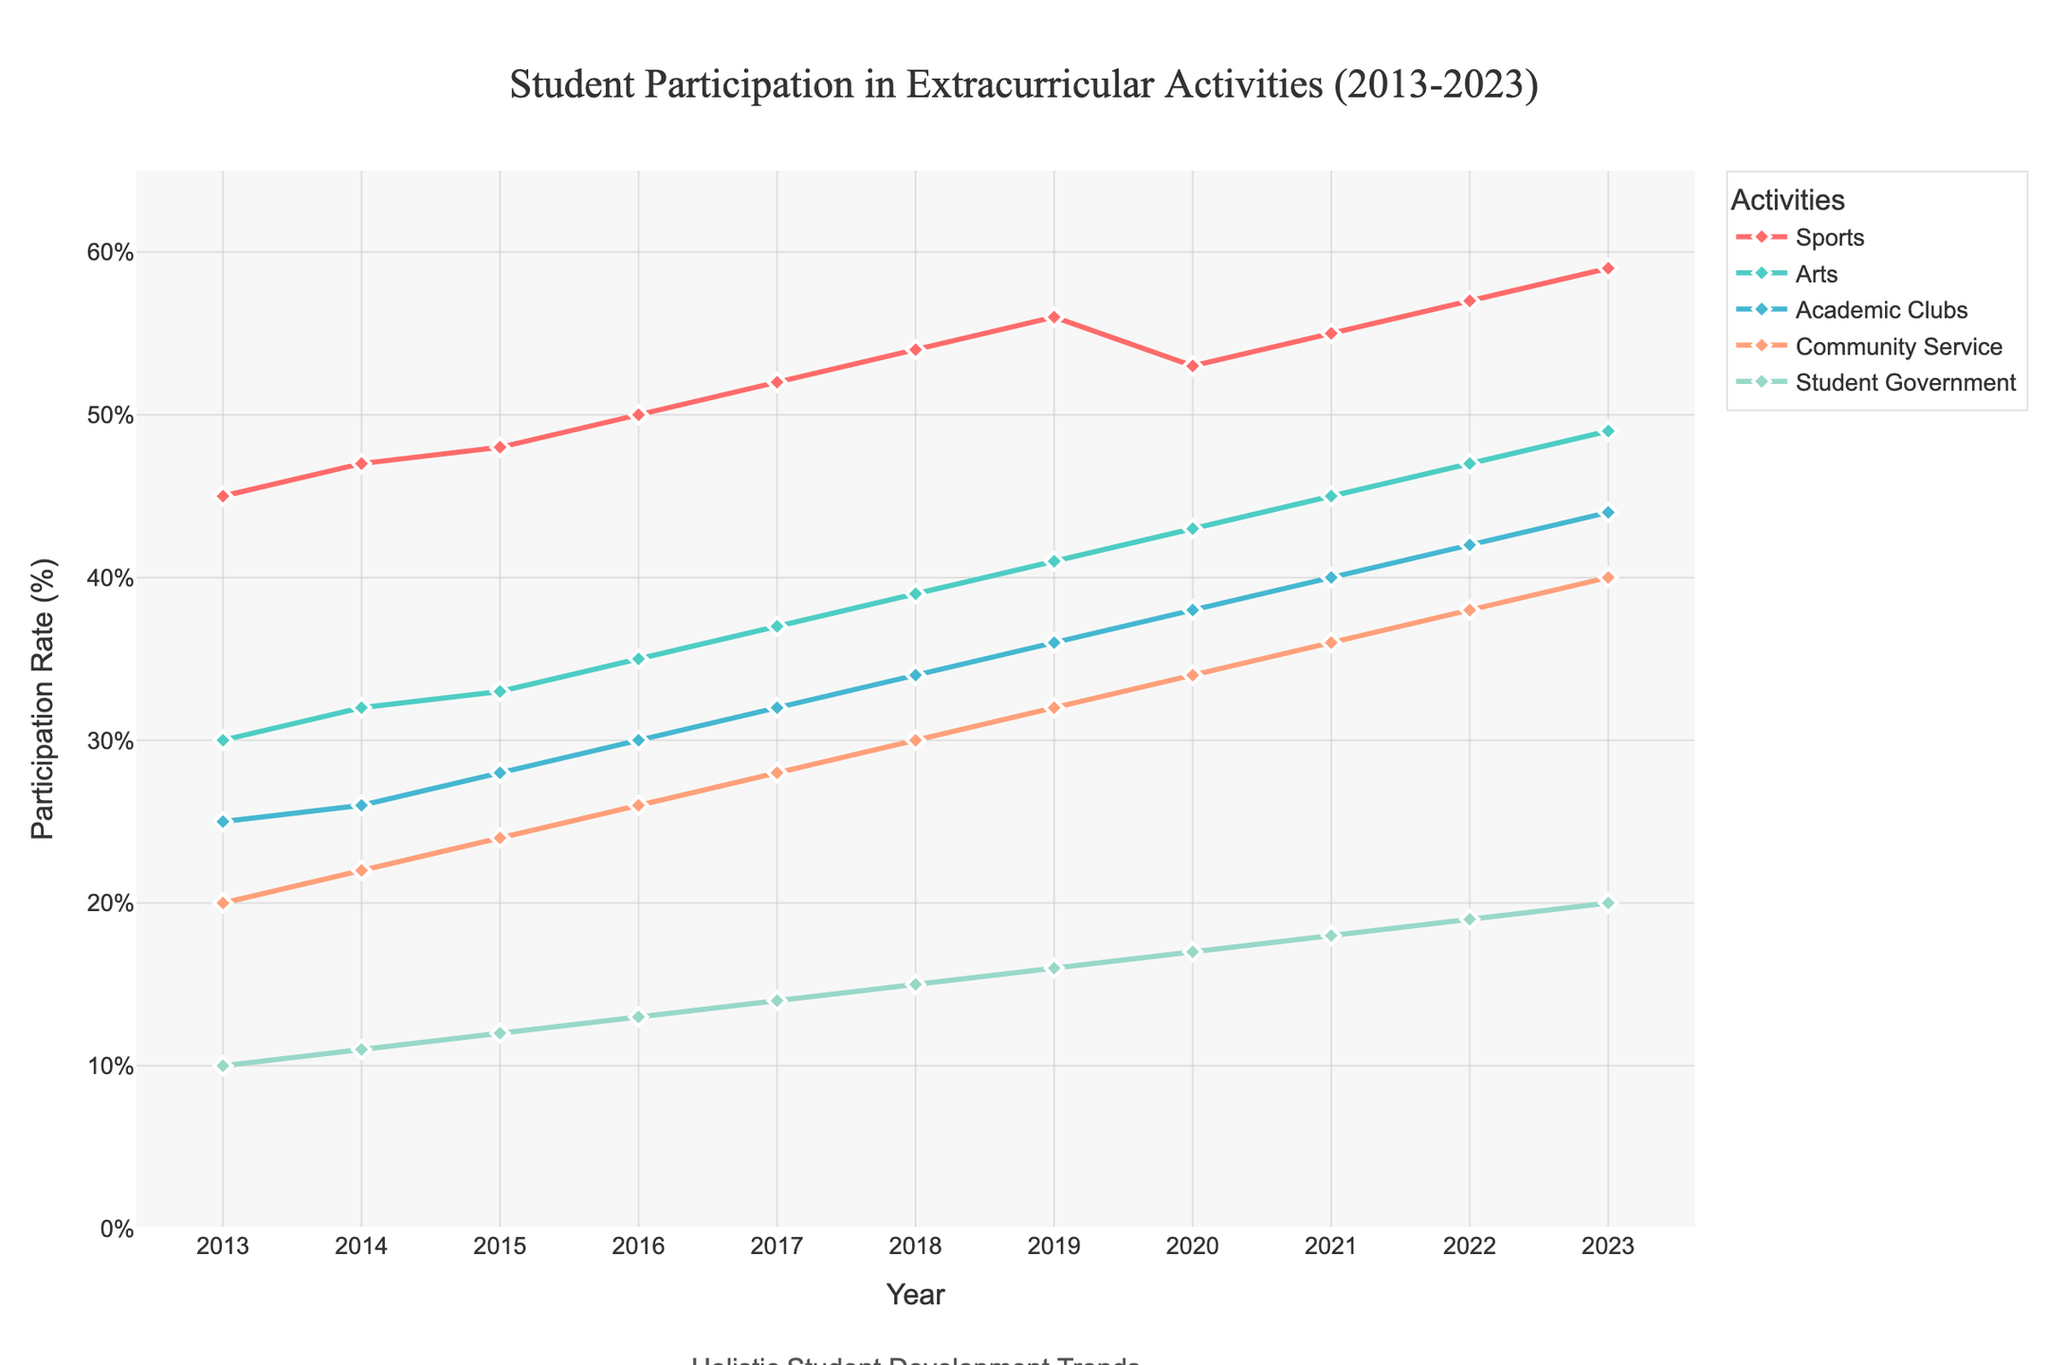What's the trend in student participation in sports from 2013 to 2023? The line for sports on the figure shows a consistent upward trend from 45% in 2013 to 59% in 2023.
Answer: Increasing Which extracurricular activity had the highest participation rate in 2015? By comparing the heights of the lines, sports had the highest participation rate at 48% in 2015.
Answer: Sports How much did the participation in Arts increase from 2013 to 2023? The participation in Arts was 30% in 2013 and increased to 49% in 2023. The increase is 49% - 30% = 19%.
Answer: 19% In which year did student government participation reach 15%? The line for student government reaches 15% in the year 2018 on the figure.
Answer: 2018 What is the difference between the participation rates in community service and academic clubs in 2023? In 2023, community service participation is at 40% and academic clubs at 44%. The difference is 44% - 40% = 4%.
Answer: 4% Which year had the highest increase in participation rate for community service? By comparing the slopes of the community service line between successive years, the steepest increase occurred between 2016 to 2017, going from 26% to 28%.
Answer: 2017 Compare the participation rates of arts and sports in 2020. In 2020, the participation rate for arts is 43%, while for sports it is 53%. Sports participation is higher than Arts by 53% - 43% = 10%.
Answer: Sports Which activity shows the least variability in participation rates over the decade? By looking at the smoothness and range of the lines, student government shows the least variability, with the narrowest range from 10% to 20%.
Answer: Student Government What was the average participation rate of academic clubs from 2013 to 2023? To find the average, add the annual participation rates: 25+26+28+30+32+34+36+38+40+42+44 = 375, then divide by 11 years: 375/11 ≈ 34.09.
Answer: 34.09% Which years did community service participation surpass that of academic clubs? On the figure, the line for community service never surpasses the line for academic clubs from 2013 to 2023.
Answer: None 